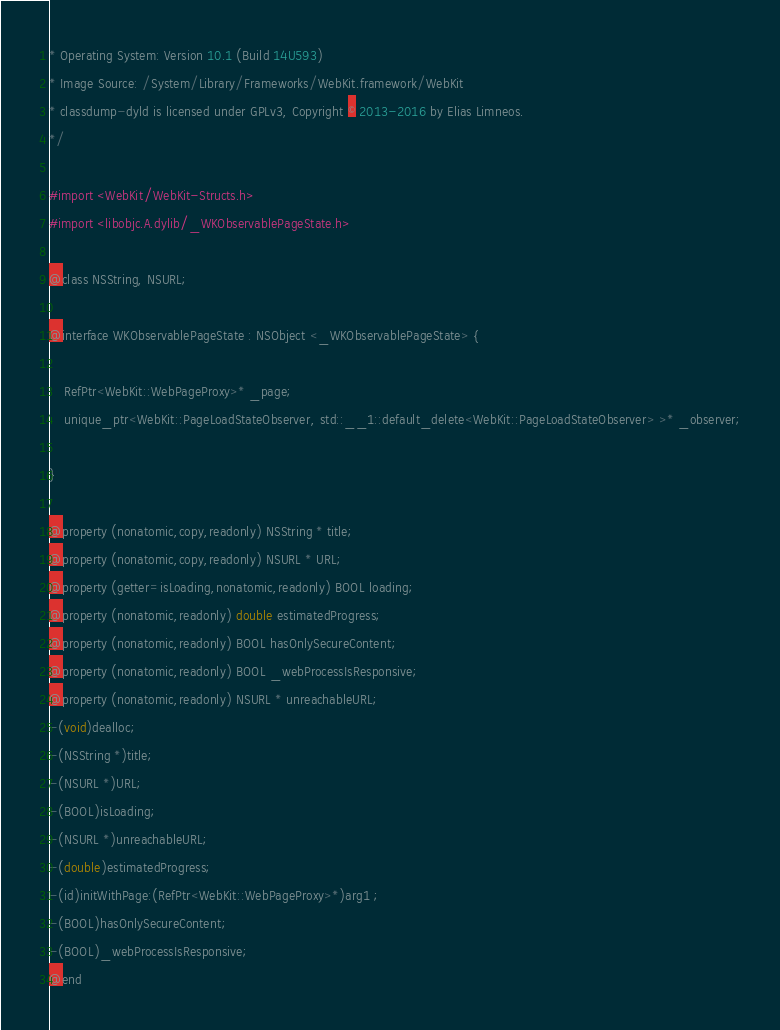Convert code to text. <code><loc_0><loc_0><loc_500><loc_500><_C_>* Operating System: Version 10.1 (Build 14U593)
* Image Source: /System/Library/Frameworks/WebKit.framework/WebKit
* classdump-dyld is licensed under GPLv3, Copyright © 2013-2016 by Elias Limneos.
*/

#import <WebKit/WebKit-Structs.h>
#import <libobjc.A.dylib/_WKObservablePageState.h>

@class NSString, NSURL;

@interface WKObservablePageState : NSObject <_WKObservablePageState> {

	RefPtr<WebKit::WebPageProxy>* _page;
	unique_ptr<WebKit::PageLoadStateObserver, std::__1::default_delete<WebKit::PageLoadStateObserver> >* _observer;

}

@property (nonatomic,copy,readonly) NSString * title; 
@property (nonatomic,copy,readonly) NSURL * URL; 
@property (getter=isLoading,nonatomic,readonly) BOOL loading; 
@property (nonatomic,readonly) double estimatedProgress; 
@property (nonatomic,readonly) BOOL hasOnlySecureContent; 
@property (nonatomic,readonly) BOOL _webProcessIsResponsive; 
@property (nonatomic,readonly) NSURL * unreachableURL; 
-(void)dealloc;
-(NSString *)title;
-(NSURL *)URL;
-(BOOL)isLoading;
-(NSURL *)unreachableURL;
-(double)estimatedProgress;
-(id)initWithPage:(RefPtr<WebKit::WebPageProxy>*)arg1 ;
-(BOOL)hasOnlySecureContent;
-(BOOL)_webProcessIsResponsive;
@end

</code> 